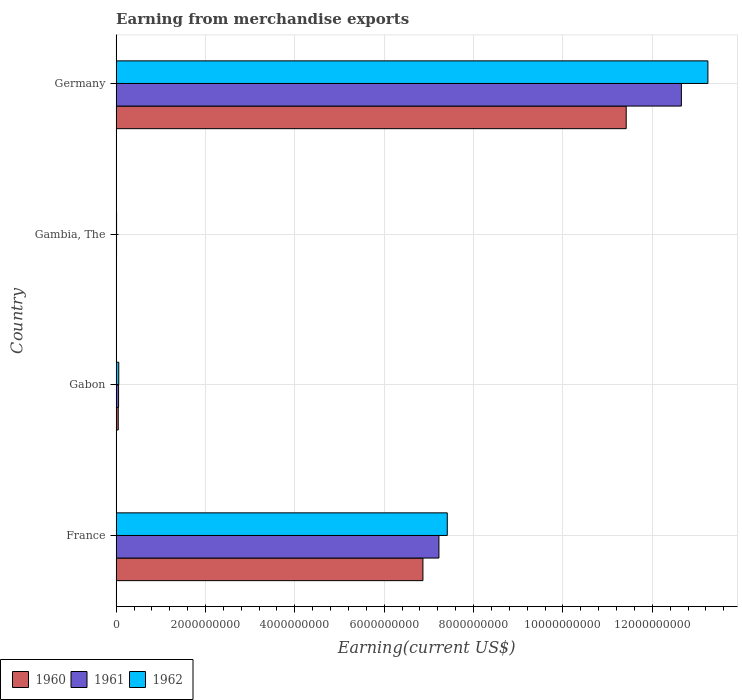How many groups of bars are there?
Your answer should be very brief. 4. Are the number of bars on each tick of the Y-axis equal?
Your answer should be compact. Yes. What is the label of the 4th group of bars from the top?
Make the answer very short. France. What is the amount earned from merchandise exports in 1962 in Germany?
Offer a terse response. 1.32e+1. Across all countries, what is the maximum amount earned from merchandise exports in 1962?
Your answer should be very brief. 1.32e+1. Across all countries, what is the minimum amount earned from merchandise exports in 1961?
Provide a succinct answer. 9.45e+06. In which country was the amount earned from merchandise exports in 1961 minimum?
Keep it short and to the point. Gambia, The. What is the total amount earned from merchandise exports in 1960 in the graph?
Offer a very short reply. 1.83e+1. What is the difference between the amount earned from merchandise exports in 1960 in France and that in Gambia, The?
Provide a short and direct response. 6.86e+09. What is the difference between the amount earned from merchandise exports in 1962 in Gabon and the amount earned from merchandise exports in 1961 in Germany?
Give a very brief answer. -1.26e+1. What is the average amount earned from merchandise exports in 1961 per country?
Offer a terse response. 4.98e+09. What is the difference between the amount earned from merchandise exports in 1961 and amount earned from merchandise exports in 1960 in France?
Make the answer very short. 3.58e+08. In how many countries, is the amount earned from merchandise exports in 1961 greater than 6800000000 US$?
Keep it short and to the point. 2. What is the ratio of the amount earned from merchandise exports in 1961 in France to that in Gabon?
Your answer should be very brief. 132.1. What is the difference between the highest and the second highest amount earned from merchandise exports in 1960?
Your answer should be compact. 4.55e+09. What is the difference between the highest and the lowest amount earned from merchandise exports in 1960?
Make the answer very short. 1.14e+1. Is the sum of the amount earned from merchandise exports in 1962 in France and Gabon greater than the maximum amount earned from merchandise exports in 1960 across all countries?
Ensure brevity in your answer.  No. What does the 3rd bar from the top in Germany represents?
Ensure brevity in your answer.  1960. What does the 1st bar from the bottom in Gabon represents?
Your answer should be very brief. 1960. What is the difference between two consecutive major ticks on the X-axis?
Provide a succinct answer. 2.00e+09. Are the values on the major ticks of X-axis written in scientific E-notation?
Provide a short and direct response. No. Does the graph contain any zero values?
Your response must be concise. No. Does the graph contain grids?
Make the answer very short. Yes. What is the title of the graph?
Keep it short and to the point. Earning from merchandise exports. Does "1972" appear as one of the legend labels in the graph?
Offer a terse response. No. What is the label or title of the X-axis?
Keep it short and to the point. Earning(current US$). What is the label or title of the Y-axis?
Your answer should be very brief. Country. What is the Earning(current US$) in 1960 in France?
Keep it short and to the point. 6.87e+09. What is the Earning(current US$) in 1961 in France?
Provide a short and direct response. 7.22e+09. What is the Earning(current US$) of 1962 in France?
Offer a very short reply. 7.41e+09. What is the Earning(current US$) in 1960 in Gabon?
Your answer should be compact. 4.74e+07. What is the Earning(current US$) of 1961 in Gabon?
Give a very brief answer. 5.47e+07. What is the Earning(current US$) in 1962 in Gabon?
Make the answer very short. 5.89e+07. What is the Earning(current US$) of 1960 in Gambia, The?
Give a very brief answer. 7.79e+06. What is the Earning(current US$) in 1961 in Gambia, The?
Provide a succinct answer. 9.45e+06. What is the Earning(current US$) of 1962 in Gambia, The?
Offer a terse response. 9.99e+06. What is the Earning(current US$) of 1960 in Germany?
Offer a very short reply. 1.14e+1. What is the Earning(current US$) in 1961 in Germany?
Make the answer very short. 1.27e+1. What is the Earning(current US$) of 1962 in Germany?
Give a very brief answer. 1.32e+1. Across all countries, what is the maximum Earning(current US$) of 1960?
Make the answer very short. 1.14e+1. Across all countries, what is the maximum Earning(current US$) of 1961?
Provide a succinct answer. 1.27e+1. Across all countries, what is the maximum Earning(current US$) in 1962?
Your response must be concise. 1.32e+1. Across all countries, what is the minimum Earning(current US$) in 1960?
Your answer should be compact. 7.79e+06. Across all countries, what is the minimum Earning(current US$) of 1961?
Offer a terse response. 9.45e+06. Across all countries, what is the minimum Earning(current US$) in 1962?
Your answer should be very brief. 9.99e+06. What is the total Earning(current US$) in 1960 in the graph?
Your answer should be compact. 1.83e+1. What is the total Earning(current US$) in 1961 in the graph?
Offer a very short reply. 1.99e+1. What is the total Earning(current US$) in 1962 in the graph?
Your response must be concise. 2.07e+1. What is the difference between the Earning(current US$) of 1960 in France and that in Gabon?
Offer a terse response. 6.82e+09. What is the difference between the Earning(current US$) in 1961 in France and that in Gabon?
Your answer should be very brief. 7.17e+09. What is the difference between the Earning(current US$) of 1962 in France and that in Gabon?
Your answer should be very brief. 7.35e+09. What is the difference between the Earning(current US$) in 1960 in France and that in Gambia, The?
Offer a very short reply. 6.86e+09. What is the difference between the Earning(current US$) of 1961 in France and that in Gambia, The?
Your response must be concise. 7.21e+09. What is the difference between the Earning(current US$) of 1962 in France and that in Gambia, The?
Ensure brevity in your answer.  7.40e+09. What is the difference between the Earning(current US$) of 1960 in France and that in Germany?
Offer a very short reply. -4.55e+09. What is the difference between the Earning(current US$) in 1961 in France and that in Germany?
Offer a terse response. -5.43e+09. What is the difference between the Earning(current US$) of 1962 in France and that in Germany?
Offer a terse response. -5.83e+09. What is the difference between the Earning(current US$) of 1960 in Gabon and that in Gambia, The?
Offer a very short reply. 3.96e+07. What is the difference between the Earning(current US$) of 1961 in Gabon and that in Gambia, The?
Keep it short and to the point. 4.52e+07. What is the difference between the Earning(current US$) of 1962 in Gabon and that in Gambia, The?
Provide a succinct answer. 4.89e+07. What is the difference between the Earning(current US$) of 1960 in Gabon and that in Germany?
Your response must be concise. -1.14e+1. What is the difference between the Earning(current US$) in 1961 in Gabon and that in Germany?
Your answer should be compact. -1.26e+1. What is the difference between the Earning(current US$) of 1962 in Gabon and that in Germany?
Ensure brevity in your answer.  -1.32e+1. What is the difference between the Earning(current US$) of 1960 in Gambia, The and that in Germany?
Provide a short and direct response. -1.14e+1. What is the difference between the Earning(current US$) of 1961 in Gambia, The and that in Germany?
Offer a terse response. -1.26e+1. What is the difference between the Earning(current US$) of 1962 in Gambia, The and that in Germany?
Ensure brevity in your answer.  -1.32e+1. What is the difference between the Earning(current US$) of 1960 in France and the Earning(current US$) of 1961 in Gabon?
Offer a very short reply. 6.81e+09. What is the difference between the Earning(current US$) of 1960 in France and the Earning(current US$) of 1962 in Gabon?
Provide a short and direct response. 6.81e+09. What is the difference between the Earning(current US$) in 1961 in France and the Earning(current US$) in 1962 in Gabon?
Make the answer very short. 7.17e+09. What is the difference between the Earning(current US$) in 1960 in France and the Earning(current US$) in 1961 in Gambia, The?
Your answer should be compact. 6.86e+09. What is the difference between the Earning(current US$) in 1960 in France and the Earning(current US$) in 1962 in Gambia, The?
Ensure brevity in your answer.  6.86e+09. What is the difference between the Earning(current US$) in 1961 in France and the Earning(current US$) in 1962 in Gambia, The?
Make the answer very short. 7.21e+09. What is the difference between the Earning(current US$) in 1960 in France and the Earning(current US$) in 1961 in Germany?
Offer a terse response. -5.78e+09. What is the difference between the Earning(current US$) of 1960 in France and the Earning(current US$) of 1962 in Germany?
Ensure brevity in your answer.  -6.38e+09. What is the difference between the Earning(current US$) of 1961 in France and the Earning(current US$) of 1962 in Germany?
Your response must be concise. -6.02e+09. What is the difference between the Earning(current US$) in 1960 in Gabon and the Earning(current US$) in 1961 in Gambia, The?
Your answer should be compact. 3.79e+07. What is the difference between the Earning(current US$) of 1960 in Gabon and the Earning(current US$) of 1962 in Gambia, The?
Give a very brief answer. 3.74e+07. What is the difference between the Earning(current US$) in 1961 in Gabon and the Earning(current US$) in 1962 in Gambia, The?
Ensure brevity in your answer.  4.47e+07. What is the difference between the Earning(current US$) of 1960 in Gabon and the Earning(current US$) of 1961 in Germany?
Provide a succinct answer. -1.26e+1. What is the difference between the Earning(current US$) in 1960 in Gabon and the Earning(current US$) in 1962 in Germany?
Provide a short and direct response. -1.32e+1. What is the difference between the Earning(current US$) of 1961 in Gabon and the Earning(current US$) of 1962 in Germany?
Give a very brief answer. -1.32e+1. What is the difference between the Earning(current US$) of 1960 in Gambia, The and the Earning(current US$) of 1961 in Germany?
Provide a short and direct response. -1.26e+1. What is the difference between the Earning(current US$) in 1960 in Gambia, The and the Earning(current US$) in 1962 in Germany?
Offer a terse response. -1.32e+1. What is the difference between the Earning(current US$) in 1961 in Gambia, The and the Earning(current US$) in 1962 in Germany?
Provide a succinct answer. -1.32e+1. What is the average Earning(current US$) of 1960 per country?
Your response must be concise. 4.58e+09. What is the average Earning(current US$) in 1961 per country?
Offer a very short reply. 4.98e+09. What is the average Earning(current US$) of 1962 per country?
Provide a short and direct response. 5.18e+09. What is the difference between the Earning(current US$) of 1960 and Earning(current US$) of 1961 in France?
Offer a very short reply. -3.58e+08. What is the difference between the Earning(current US$) of 1960 and Earning(current US$) of 1962 in France?
Provide a succinct answer. -5.45e+08. What is the difference between the Earning(current US$) of 1961 and Earning(current US$) of 1962 in France?
Your answer should be very brief. -1.87e+08. What is the difference between the Earning(current US$) of 1960 and Earning(current US$) of 1961 in Gabon?
Your answer should be compact. -7.33e+06. What is the difference between the Earning(current US$) in 1960 and Earning(current US$) in 1962 in Gabon?
Ensure brevity in your answer.  -1.15e+07. What is the difference between the Earning(current US$) in 1961 and Earning(current US$) in 1962 in Gabon?
Keep it short and to the point. -4.21e+06. What is the difference between the Earning(current US$) of 1960 and Earning(current US$) of 1961 in Gambia, The?
Make the answer very short. -1.66e+06. What is the difference between the Earning(current US$) in 1960 and Earning(current US$) in 1962 in Gambia, The?
Keep it short and to the point. -2.20e+06. What is the difference between the Earning(current US$) of 1961 and Earning(current US$) of 1962 in Gambia, The?
Give a very brief answer. -5.43e+05. What is the difference between the Earning(current US$) in 1960 and Earning(current US$) in 1961 in Germany?
Provide a succinct answer. -1.24e+09. What is the difference between the Earning(current US$) of 1960 and Earning(current US$) of 1962 in Germany?
Give a very brief answer. -1.83e+09. What is the difference between the Earning(current US$) of 1961 and Earning(current US$) of 1962 in Germany?
Provide a succinct answer. -5.93e+08. What is the ratio of the Earning(current US$) of 1960 in France to that in Gabon?
Give a very brief answer. 145. What is the ratio of the Earning(current US$) of 1961 in France to that in Gabon?
Your answer should be very brief. 132.1. What is the ratio of the Earning(current US$) of 1962 in France to that in Gabon?
Your answer should be very brief. 125.82. What is the ratio of the Earning(current US$) in 1960 in France to that in Gambia, The?
Your answer should be compact. 881.48. What is the ratio of the Earning(current US$) in 1961 in France to that in Gambia, The?
Ensure brevity in your answer.  764.71. What is the ratio of the Earning(current US$) in 1962 in France to that in Gambia, The?
Your answer should be compact. 741.82. What is the ratio of the Earning(current US$) of 1960 in France to that in Germany?
Keep it short and to the point. 0.6. What is the ratio of the Earning(current US$) in 1961 in France to that in Germany?
Ensure brevity in your answer.  0.57. What is the ratio of the Earning(current US$) of 1962 in France to that in Germany?
Give a very brief answer. 0.56. What is the ratio of the Earning(current US$) of 1960 in Gabon to that in Gambia, The?
Your answer should be very brief. 6.08. What is the ratio of the Earning(current US$) of 1961 in Gabon to that in Gambia, The?
Your answer should be compact. 5.79. What is the ratio of the Earning(current US$) of 1962 in Gabon to that in Gambia, The?
Provide a short and direct response. 5.9. What is the ratio of the Earning(current US$) of 1960 in Gabon to that in Germany?
Offer a very short reply. 0. What is the ratio of the Earning(current US$) of 1961 in Gabon to that in Germany?
Your answer should be very brief. 0. What is the ratio of the Earning(current US$) of 1962 in Gabon to that in Germany?
Make the answer very short. 0. What is the ratio of the Earning(current US$) of 1960 in Gambia, The to that in Germany?
Keep it short and to the point. 0. What is the ratio of the Earning(current US$) in 1961 in Gambia, The to that in Germany?
Provide a short and direct response. 0. What is the ratio of the Earning(current US$) of 1962 in Gambia, The to that in Germany?
Keep it short and to the point. 0. What is the difference between the highest and the second highest Earning(current US$) of 1960?
Make the answer very short. 4.55e+09. What is the difference between the highest and the second highest Earning(current US$) in 1961?
Keep it short and to the point. 5.43e+09. What is the difference between the highest and the second highest Earning(current US$) in 1962?
Ensure brevity in your answer.  5.83e+09. What is the difference between the highest and the lowest Earning(current US$) of 1960?
Provide a succinct answer. 1.14e+1. What is the difference between the highest and the lowest Earning(current US$) of 1961?
Your response must be concise. 1.26e+1. What is the difference between the highest and the lowest Earning(current US$) of 1962?
Offer a very short reply. 1.32e+1. 